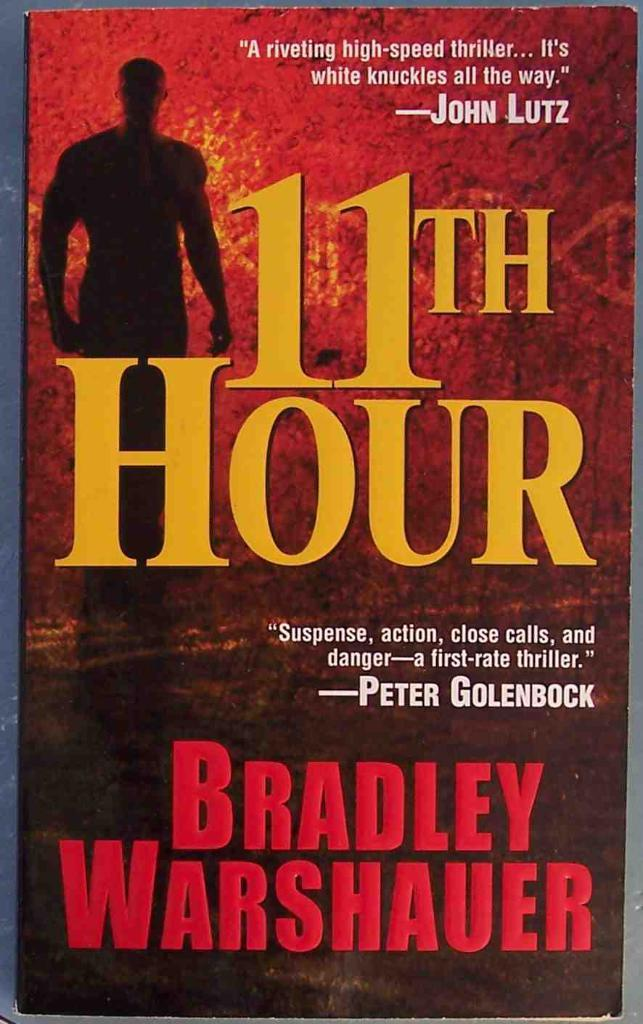Provide a one-sentence caption for the provided image. The book the 11th Hour by Bradley Warshauer is shown. 